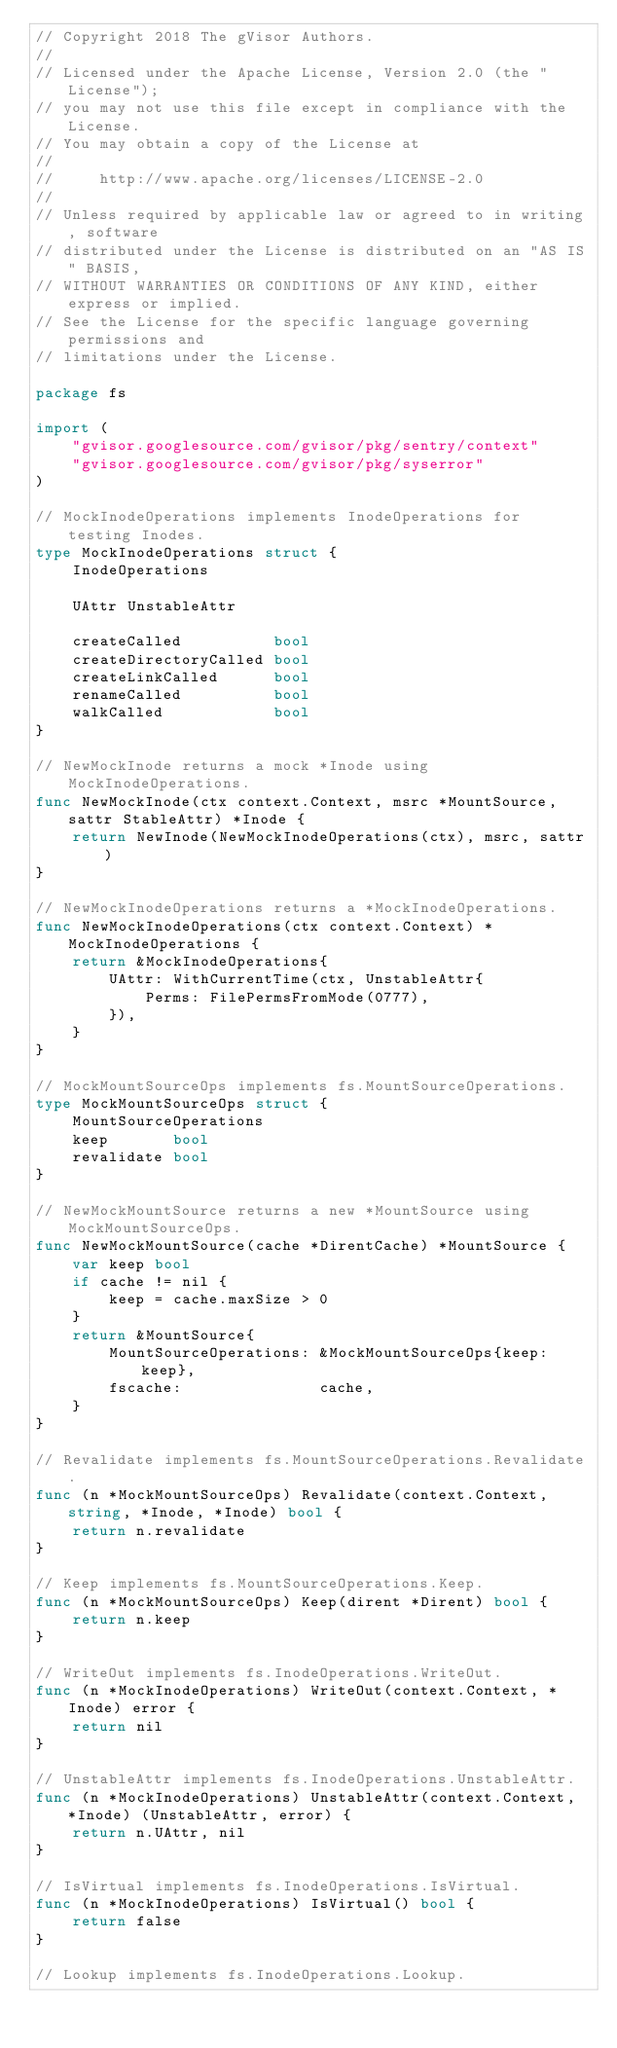Convert code to text. <code><loc_0><loc_0><loc_500><loc_500><_Go_>// Copyright 2018 The gVisor Authors.
//
// Licensed under the Apache License, Version 2.0 (the "License");
// you may not use this file except in compliance with the License.
// You may obtain a copy of the License at
//
//     http://www.apache.org/licenses/LICENSE-2.0
//
// Unless required by applicable law or agreed to in writing, software
// distributed under the License is distributed on an "AS IS" BASIS,
// WITHOUT WARRANTIES OR CONDITIONS OF ANY KIND, either express or implied.
// See the License for the specific language governing permissions and
// limitations under the License.

package fs

import (
	"gvisor.googlesource.com/gvisor/pkg/sentry/context"
	"gvisor.googlesource.com/gvisor/pkg/syserror"
)

// MockInodeOperations implements InodeOperations for testing Inodes.
type MockInodeOperations struct {
	InodeOperations

	UAttr UnstableAttr

	createCalled          bool
	createDirectoryCalled bool
	createLinkCalled      bool
	renameCalled          bool
	walkCalled            bool
}

// NewMockInode returns a mock *Inode using MockInodeOperations.
func NewMockInode(ctx context.Context, msrc *MountSource, sattr StableAttr) *Inode {
	return NewInode(NewMockInodeOperations(ctx), msrc, sattr)
}

// NewMockInodeOperations returns a *MockInodeOperations.
func NewMockInodeOperations(ctx context.Context) *MockInodeOperations {
	return &MockInodeOperations{
		UAttr: WithCurrentTime(ctx, UnstableAttr{
			Perms: FilePermsFromMode(0777),
		}),
	}
}

// MockMountSourceOps implements fs.MountSourceOperations.
type MockMountSourceOps struct {
	MountSourceOperations
	keep       bool
	revalidate bool
}

// NewMockMountSource returns a new *MountSource using MockMountSourceOps.
func NewMockMountSource(cache *DirentCache) *MountSource {
	var keep bool
	if cache != nil {
		keep = cache.maxSize > 0
	}
	return &MountSource{
		MountSourceOperations: &MockMountSourceOps{keep: keep},
		fscache:               cache,
	}
}

// Revalidate implements fs.MountSourceOperations.Revalidate.
func (n *MockMountSourceOps) Revalidate(context.Context, string, *Inode, *Inode) bool {
	return n.revalidate
}

// Keep implements fs.MountSourceOperations.Keep.
func (n *MockMountSourceOps) Keep(dirent *Dirent) bool {
	return n.keep
}

// WriteOut implements fs.InodeOperations.WriteOut.
func (n *MockInodeOperations) WriteOut(context.Context, *Inode) error {
	return nil
}

// UnstableAttr implements fs.InodeOperations.UnstableAttr.
func (n *MockInodeOperations) UnstableAttr(context.Context, *Inode) (UnstableAttr, error) {
	return n.UAttr, nil
}

// IsVirtual implements fs.InodeOperations.IsVirtual.
func (n *MockInodeOperations) IsVirtual() bool {
	return false
}

// Lookup implements fs.InodeOperations.Lookup.</code> 